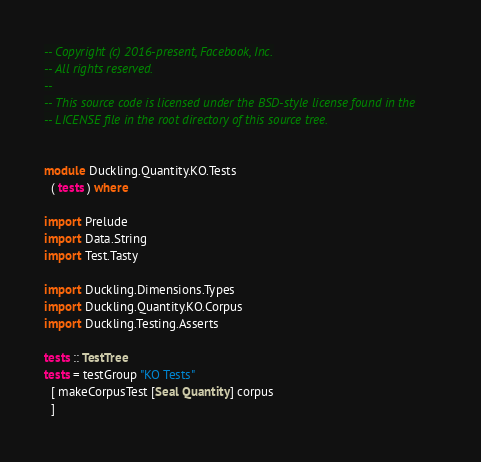Convert code to text. <code><loc_0><loc_0><loc_500><loc_500><_Haskell_>-- Copyright (c) 2016-present, Facebook, Inc.
-- All rights reserved.
--
-- This source code is licensed under the BSD-style license found in the
-- LICENSE file in the root directory of this source tree.


module Duckling.Quantity.KO.Tests
  ( tests ) where

import Prelude
import Data.String
import Test.Tasty

import Duckling.Dimensions.Types
import Duckling.Quantity.KO.Corpus
import Duckling.Testing.Asserts

tests :: TestTree
tests = testGroup "KO Tests"
  [ makeCorpusTest [Seal Quantity] corpus
  ]
</code> 